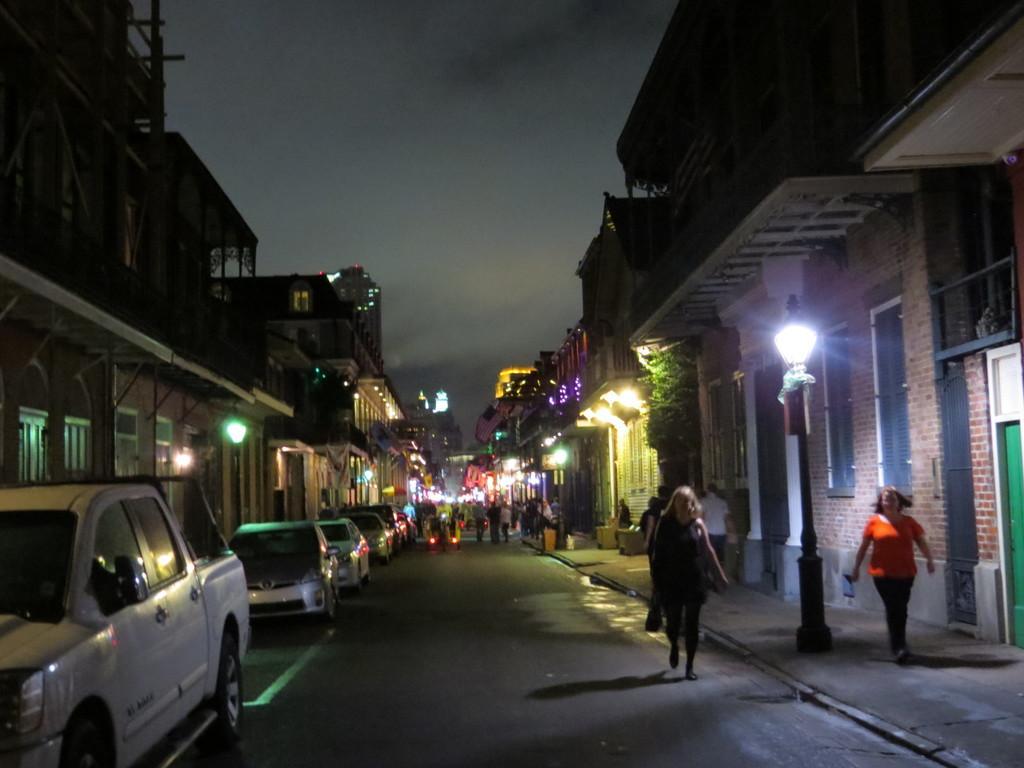How would you summarize this image in a sentence or two? There are buildings and people, there are vehicles on the road, this is sky. 